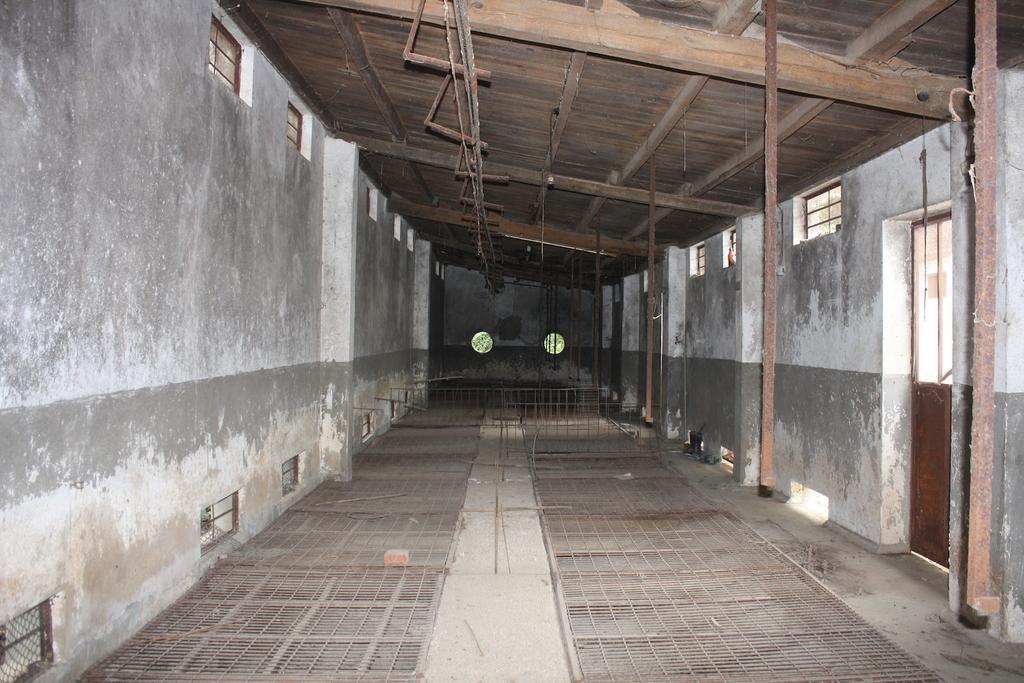In one or two sentences, can you explain what this image depicts? Here in this picture we can see some iron gates and railing present on the floor and at the top we can see a wooden roof present and on either side of it we can see ventilation windows present on the walls and on the right side we can see doors also present. 